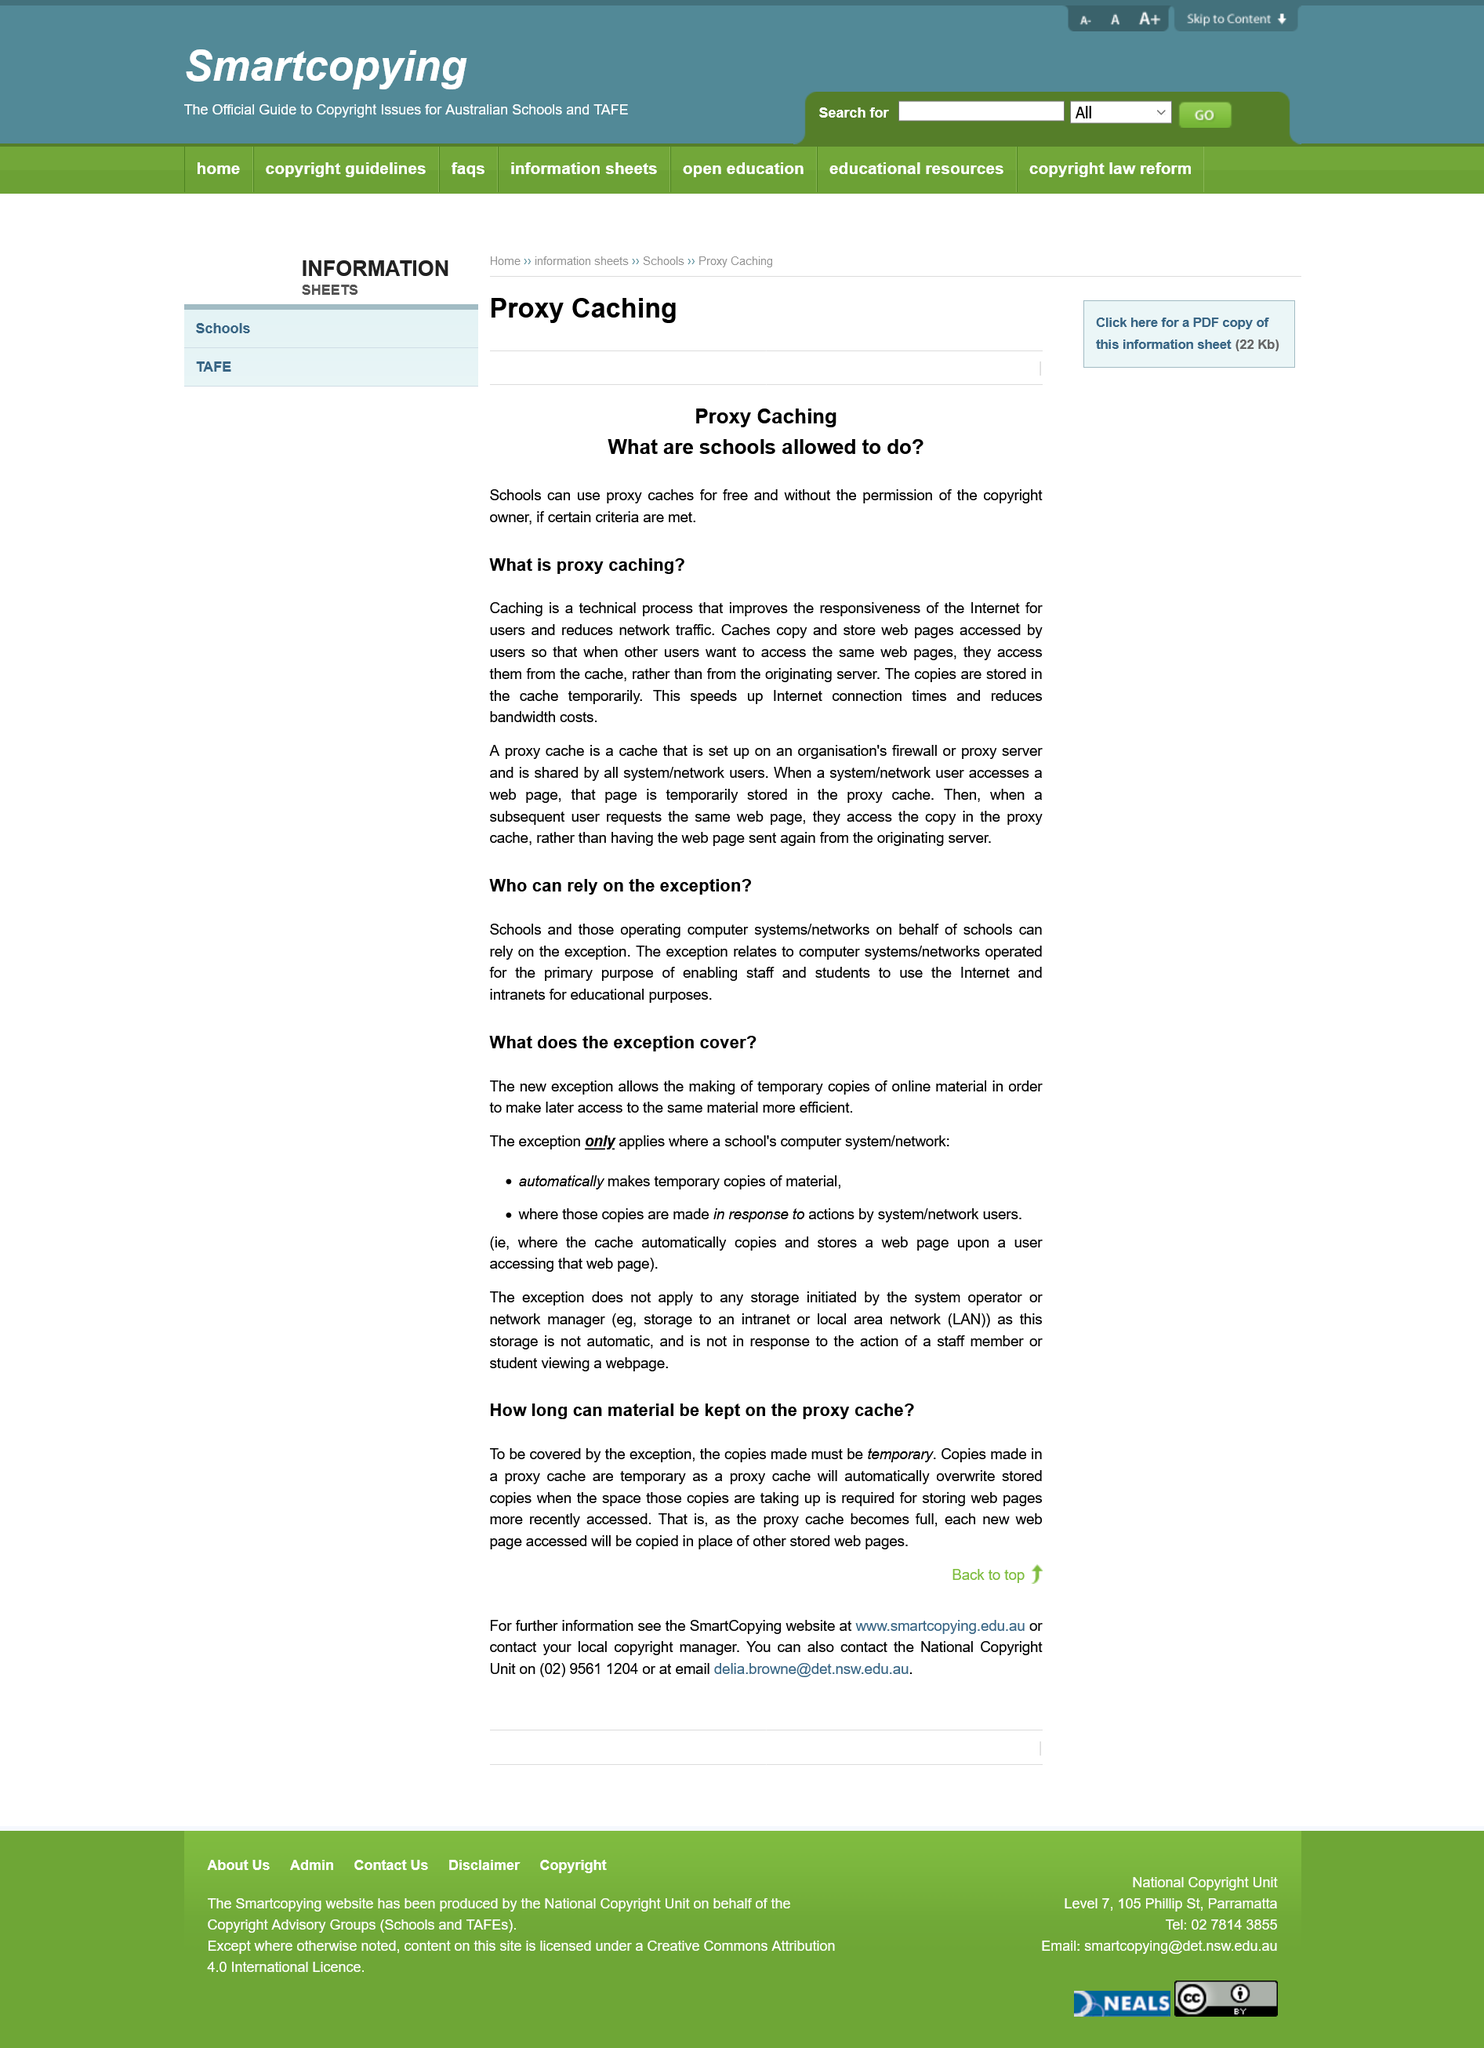Highlight a few significant elements in this photo. Schools can use proxy caches for free if they meet certain criteria. It is permissible for schools to use proxy caches without the copyright owner's permission if certain conditions are met. It is permissible for schools and entities responsible for operating IT systems on their behalf to rely on the exception. The exception relates to IT systems operated for the primary purpose of enabling staff and students to use the Internet and intranets for educational purposes. The use of a proxy cache can potentially speed up Internet connection times. 